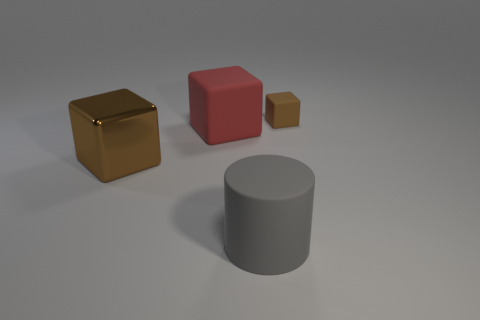There is a rubber cube that is on the right side of the gray matte cylinder; is it the same size as the rubber cylinder?
Provide a short and direct response. No. How many other things are there of the same size as the brown rubber block?
Make the answer very short. 0. Are there any green things?
Ensure brevity in your answer.  No. There is a brown object right of the brown object that is on the left side of the gray thing; what is its size?
Give a very brief answer. Small. There is a block that is left of the big rubber block; is its color the same as the block to the right of the rubber cylinder?
Offer a terse response. Yes. What color is the object that is on the right side of the large red rubber object and in front of the red cube?
Offer a terse response. Gray. What number of other objects are there of the same shape as the big brown object?
Make the answer very short. 2. What color is the metallic thing that is the same size as the matte cylinder?
Give a very brief answer. Brown. What color is the matte block that is on the left side of the gray rubber cylinder?
Give a very brief answer. Red. Is there a large red object behind the brown block in front of the red matte thing?
Ensure brevity in your answer.  Yes. 